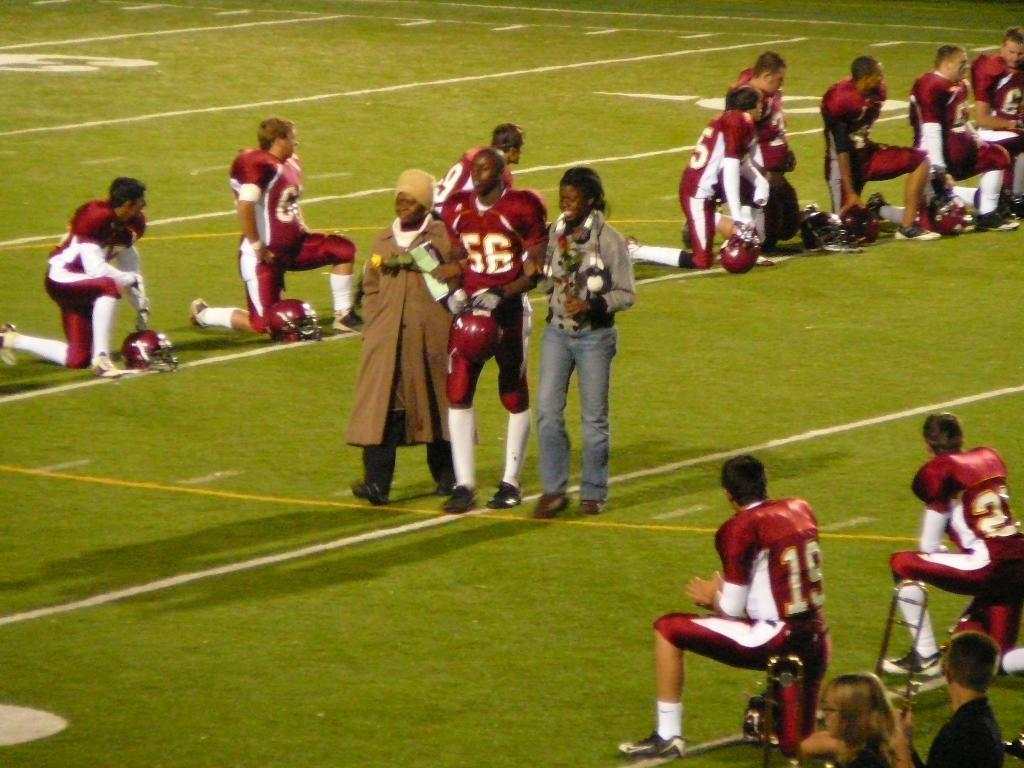How many people are present in the image? There are many people in the image. What are some of the people wearing in the image? Some of the people are wearing helmets in the image. What type of surface is visible on the ground in the image? There is grass on the ground in the image. What type of silk material can be seen being used for a discussion in the image? There is no silk material or discussion present in the image. How many times does the person in the image sneeze? There is no indication of anyone sneezing in the image. 